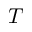Convert formula to latex. <formula><loc_0><loc_0><loc_500><loc_500>T</formula> 